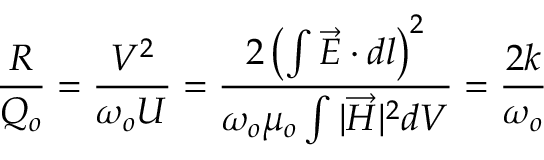<formula> <loc_0><loc_0><loc_500><loc_500>{ \frac { R } { Q _ { o } } } = { \frac { V ^ { 2 } } { \omega _ { o } U } } = { \frac { 2 \left ( \int { { \overrightarrow { E } } \cdot d l } \right ) ^ { 2 } } { \omega _ { o } \mu _ { o } \int { | { \overrightarrow { H } } | ^ { 2 } d V } } } = { \frac { 2 k } { \omega _ { o } } }</formula> 